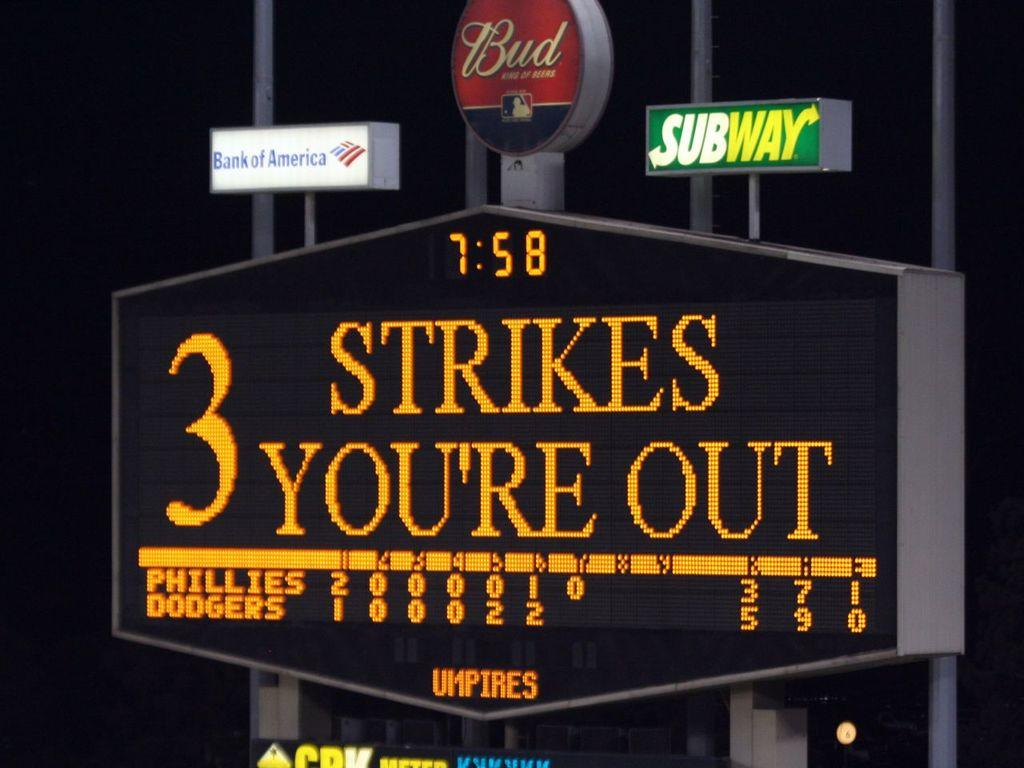Provide a one-sentence caption for the provided image. A sign at a ballpark reading 3 strikes your out. 